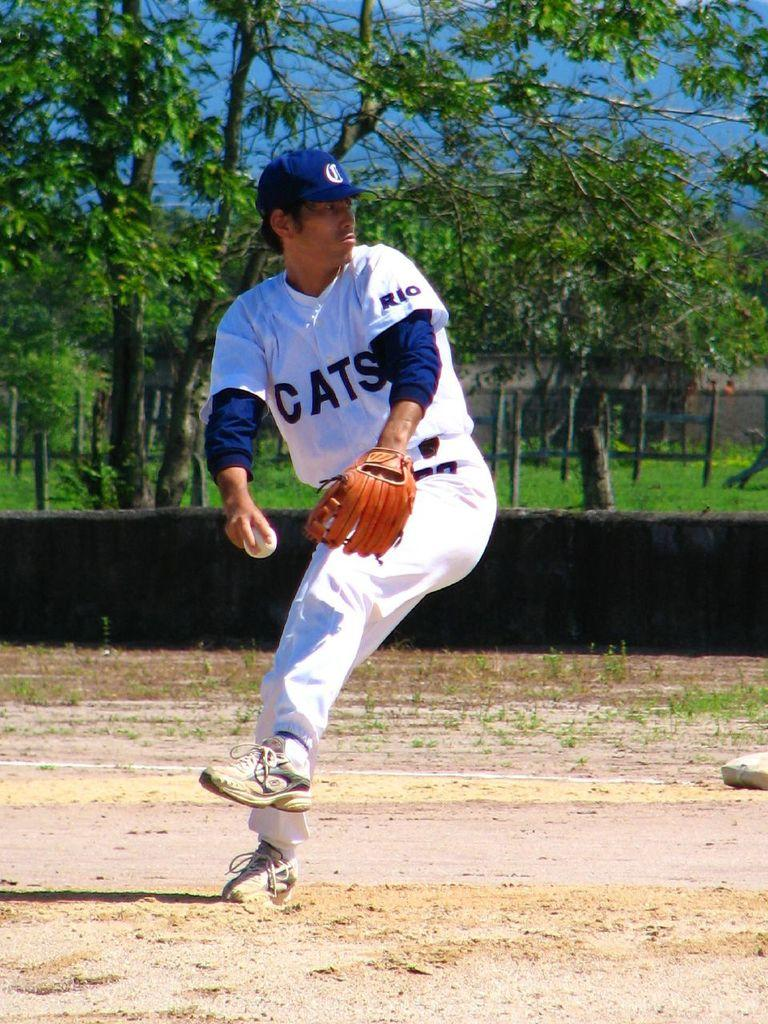<image>
Provide a brief description of the given image. cats pitcher in white getting ready to throw the ball 